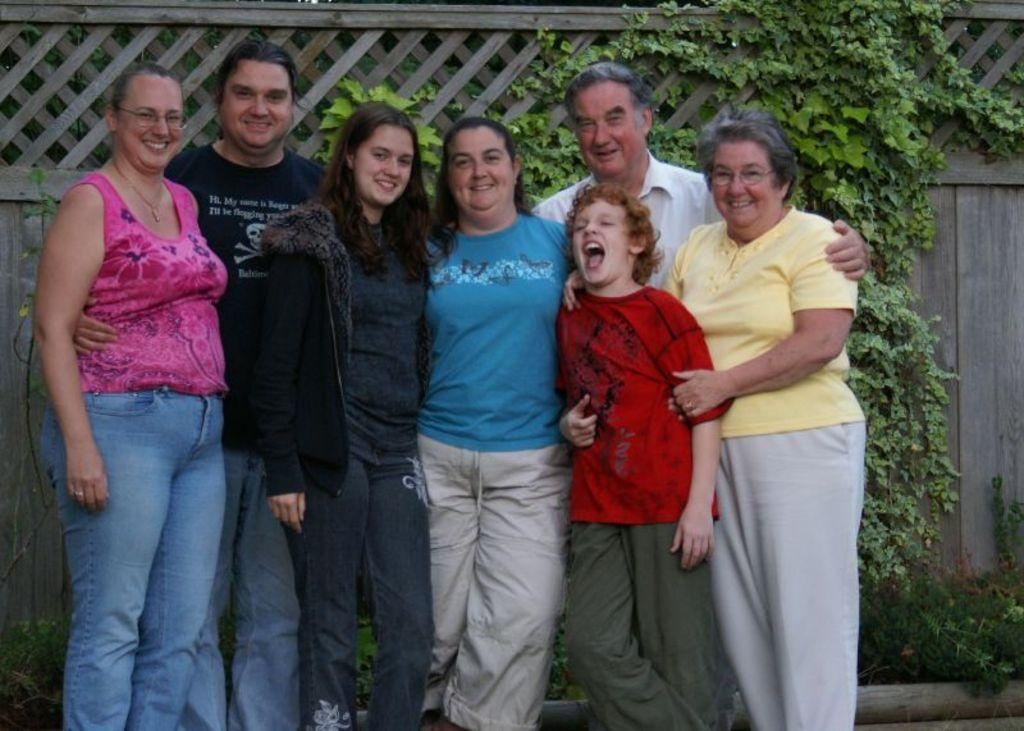How many people are in the image? There is a group of people in the image. What are the people in the image doing? The people are standing and smiling. Can you describe any specific features of the people in the image? There are people wearing glasses in the image. What can be seen in the background of the image? There is wooden fencing and plants in the background of the image. What type of sack is being used by the carpenter in the image? There is no carpenter or sack present in the image. How many seeds can be seen in the image? There are no seeds visible in the image. 